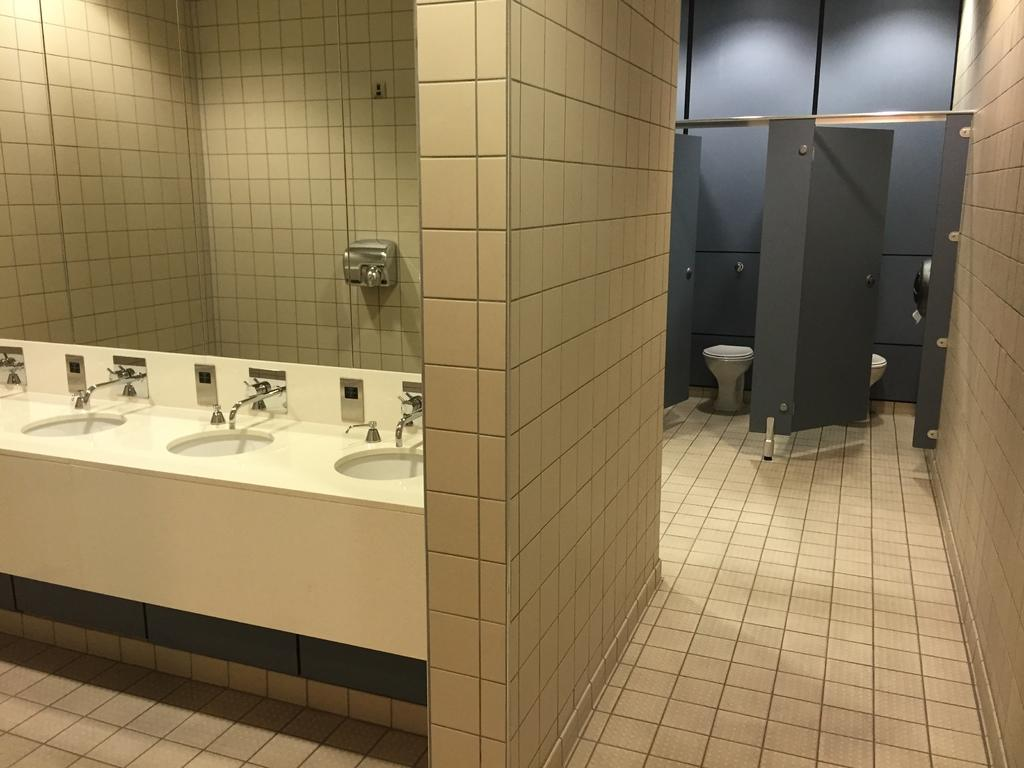What type of fixtures are present in the image? There are sinks and taps in the image. What other facilities can be seen in the image? There are toilet seats in the image. Are there any access points or entrances visible in the image? Yes, there are doors in the image. What type of pen is being used to draw on the shade in the image? There is no pen or shade present in the image; it features sinks, taps, toilet seats, and doors. 